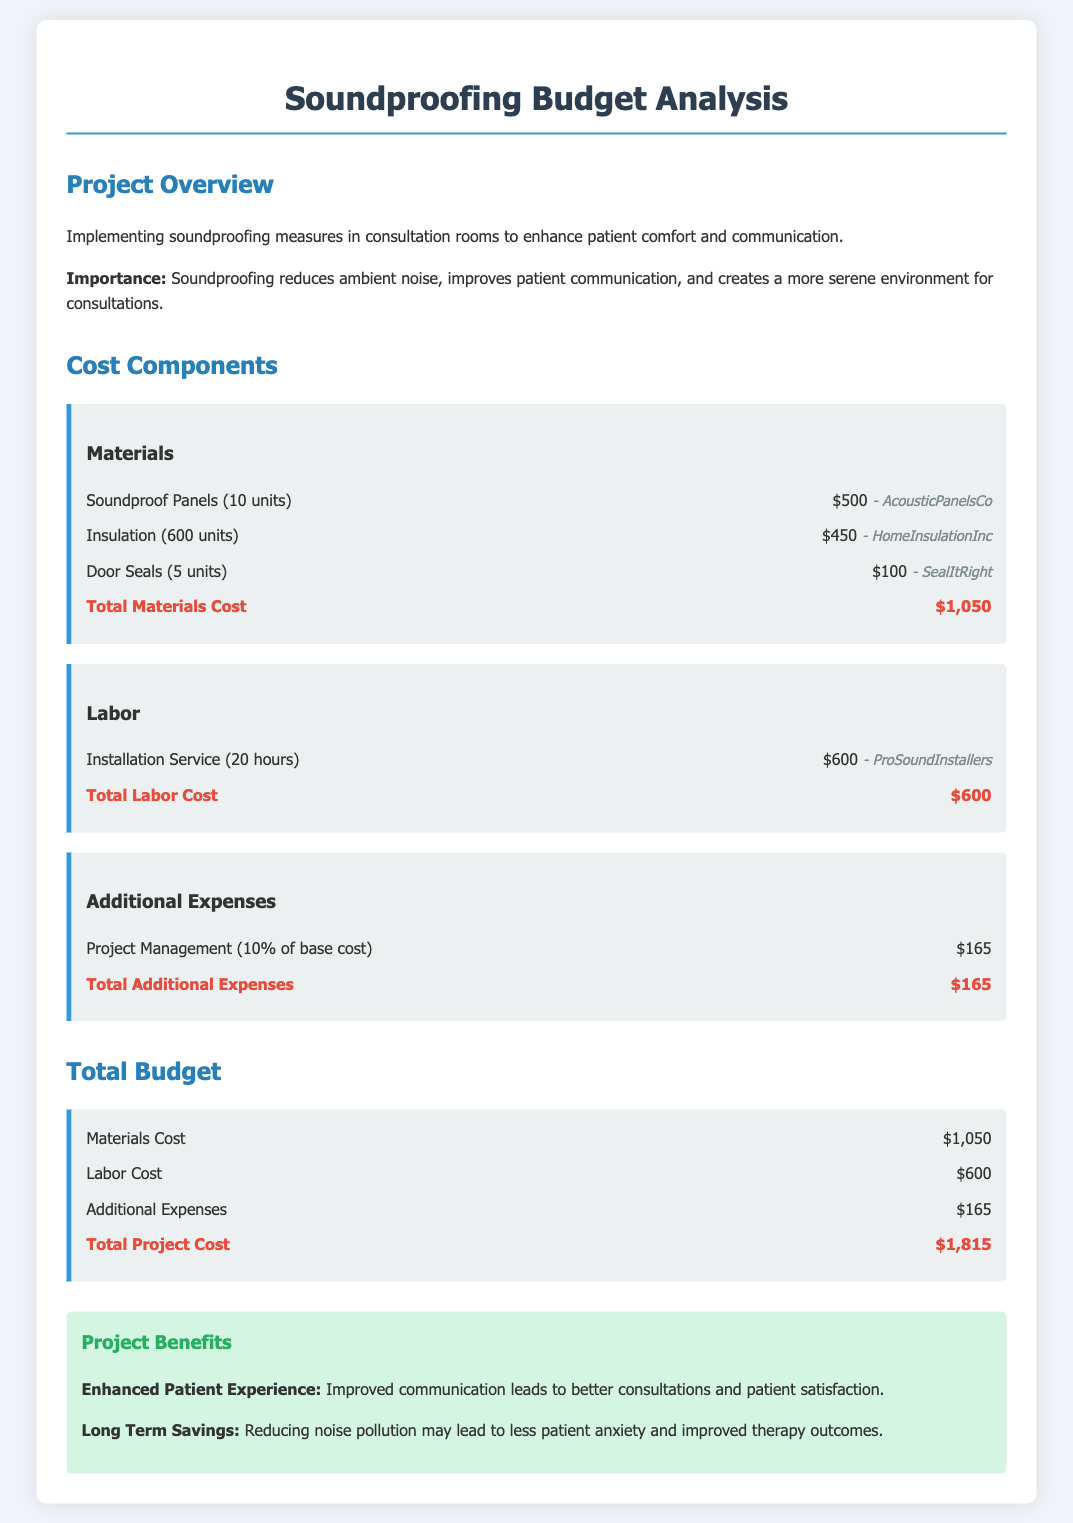what is the total cost of materials? The total cost of materials is detailed in the "Materials" section and amounts to $1,050.
Answer: $1,050 how many hours of installation service are required? The document specifies that 20 hours of installation service are needed under the "Labor" section.
Answer: 20 hours who is the supplier for door seals? The supplier for door seals is mentioned under the "Materials" section and listed as SealItRight.
Answer: SealItRight what is the total project cost? The "Total Project Cost" outlined in the document calculates to $1,815, which sums all budget components.
Answer: $1,815 what percentage of the base cost is allocated to project management? The document indicates that project management covers 10% of the base cost in the "Additional Expenses" section.
Answer: 10% how many soundproof panels are being purchased? According to the "Materials" section, there are 10 units of soundproof panels being purchased.
Answer: 10 units what is the benefit related to the patient experience? The document states that improved communication leads to better consultations and patient satisfaction.
Answer: Improved communication what is the purpose of implementing soundproofing measures? The overview section explains that the purpose is to enhance patient comfort and communication.
Answer: Enhance patient comfort and communication how much does the installation service cost? The "Labor" section specifies that the installation service costs $600.
Answer: $600 